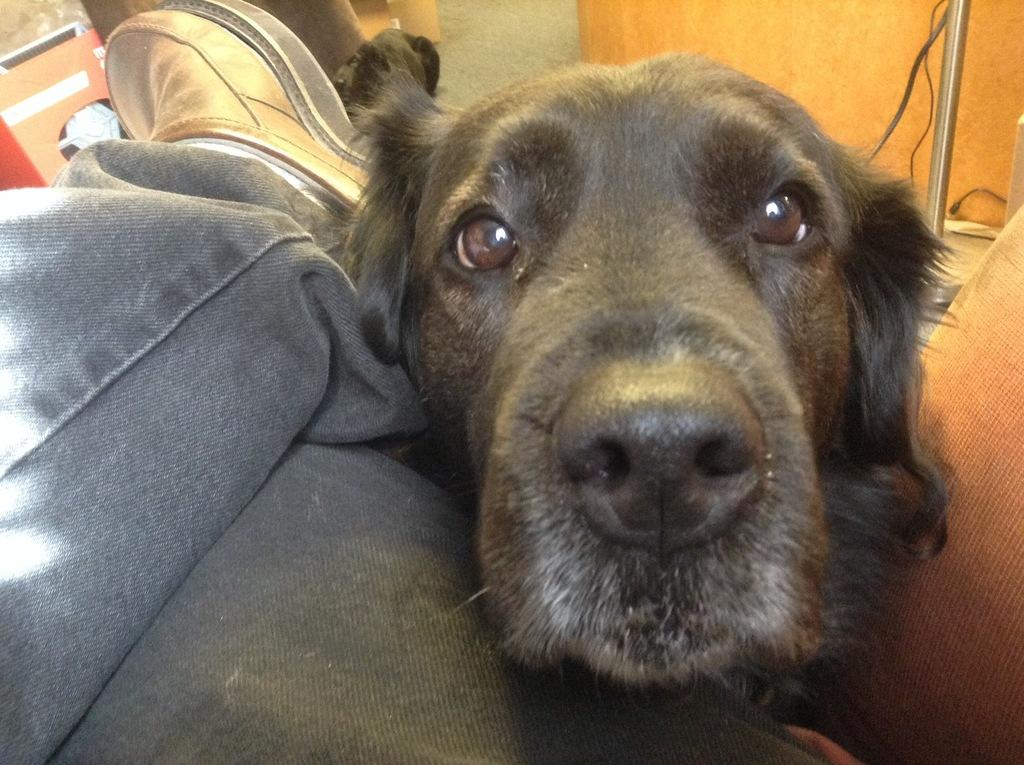What animal is present in the image? There is a dog in the image. Where is the dog located in relation to a person? The dog is beside a person's legs. What type of mask is the dog wearing in the image? There is no mask present on the dog in the image. 